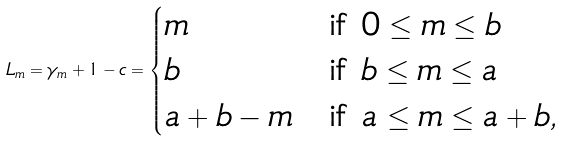Convert formula to latex. <formula><loc_0><loc_0><loc_500><loc_500>L _ { m } = \gamma _ { m } + 1 - c = \begin{cases} m & \text {if $0\leq m\leq b$} \\ b & \text {if $b\leq m\leq a$} \\ a + b - m & \text {if $a\leq m\leq a+b$} , \end{cases}</formula> 